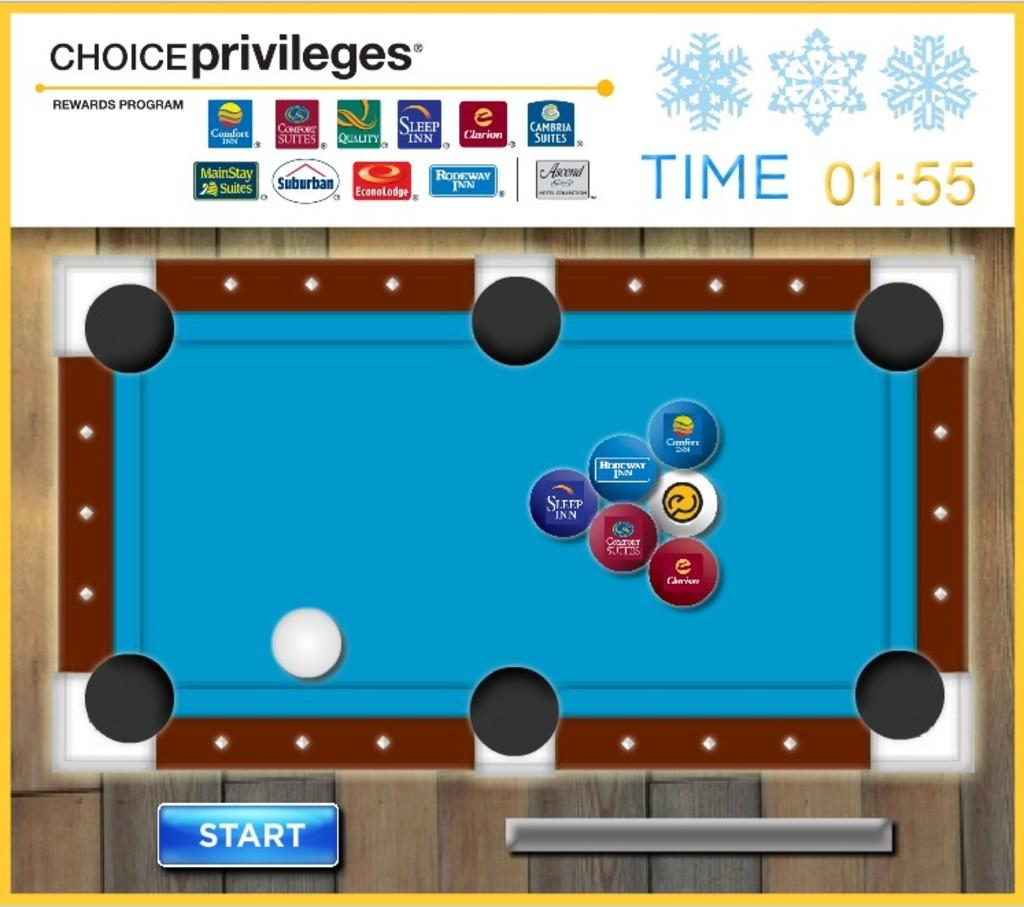What is being displayed on the screen in the image? There is a game visible on the screen in the image. What type of train can be seen in the image? There is no train present in the image; it only shows a game on the screen. What role does the person in the image play in the game? The image does not show a person or any indication of a role being played in the game. 